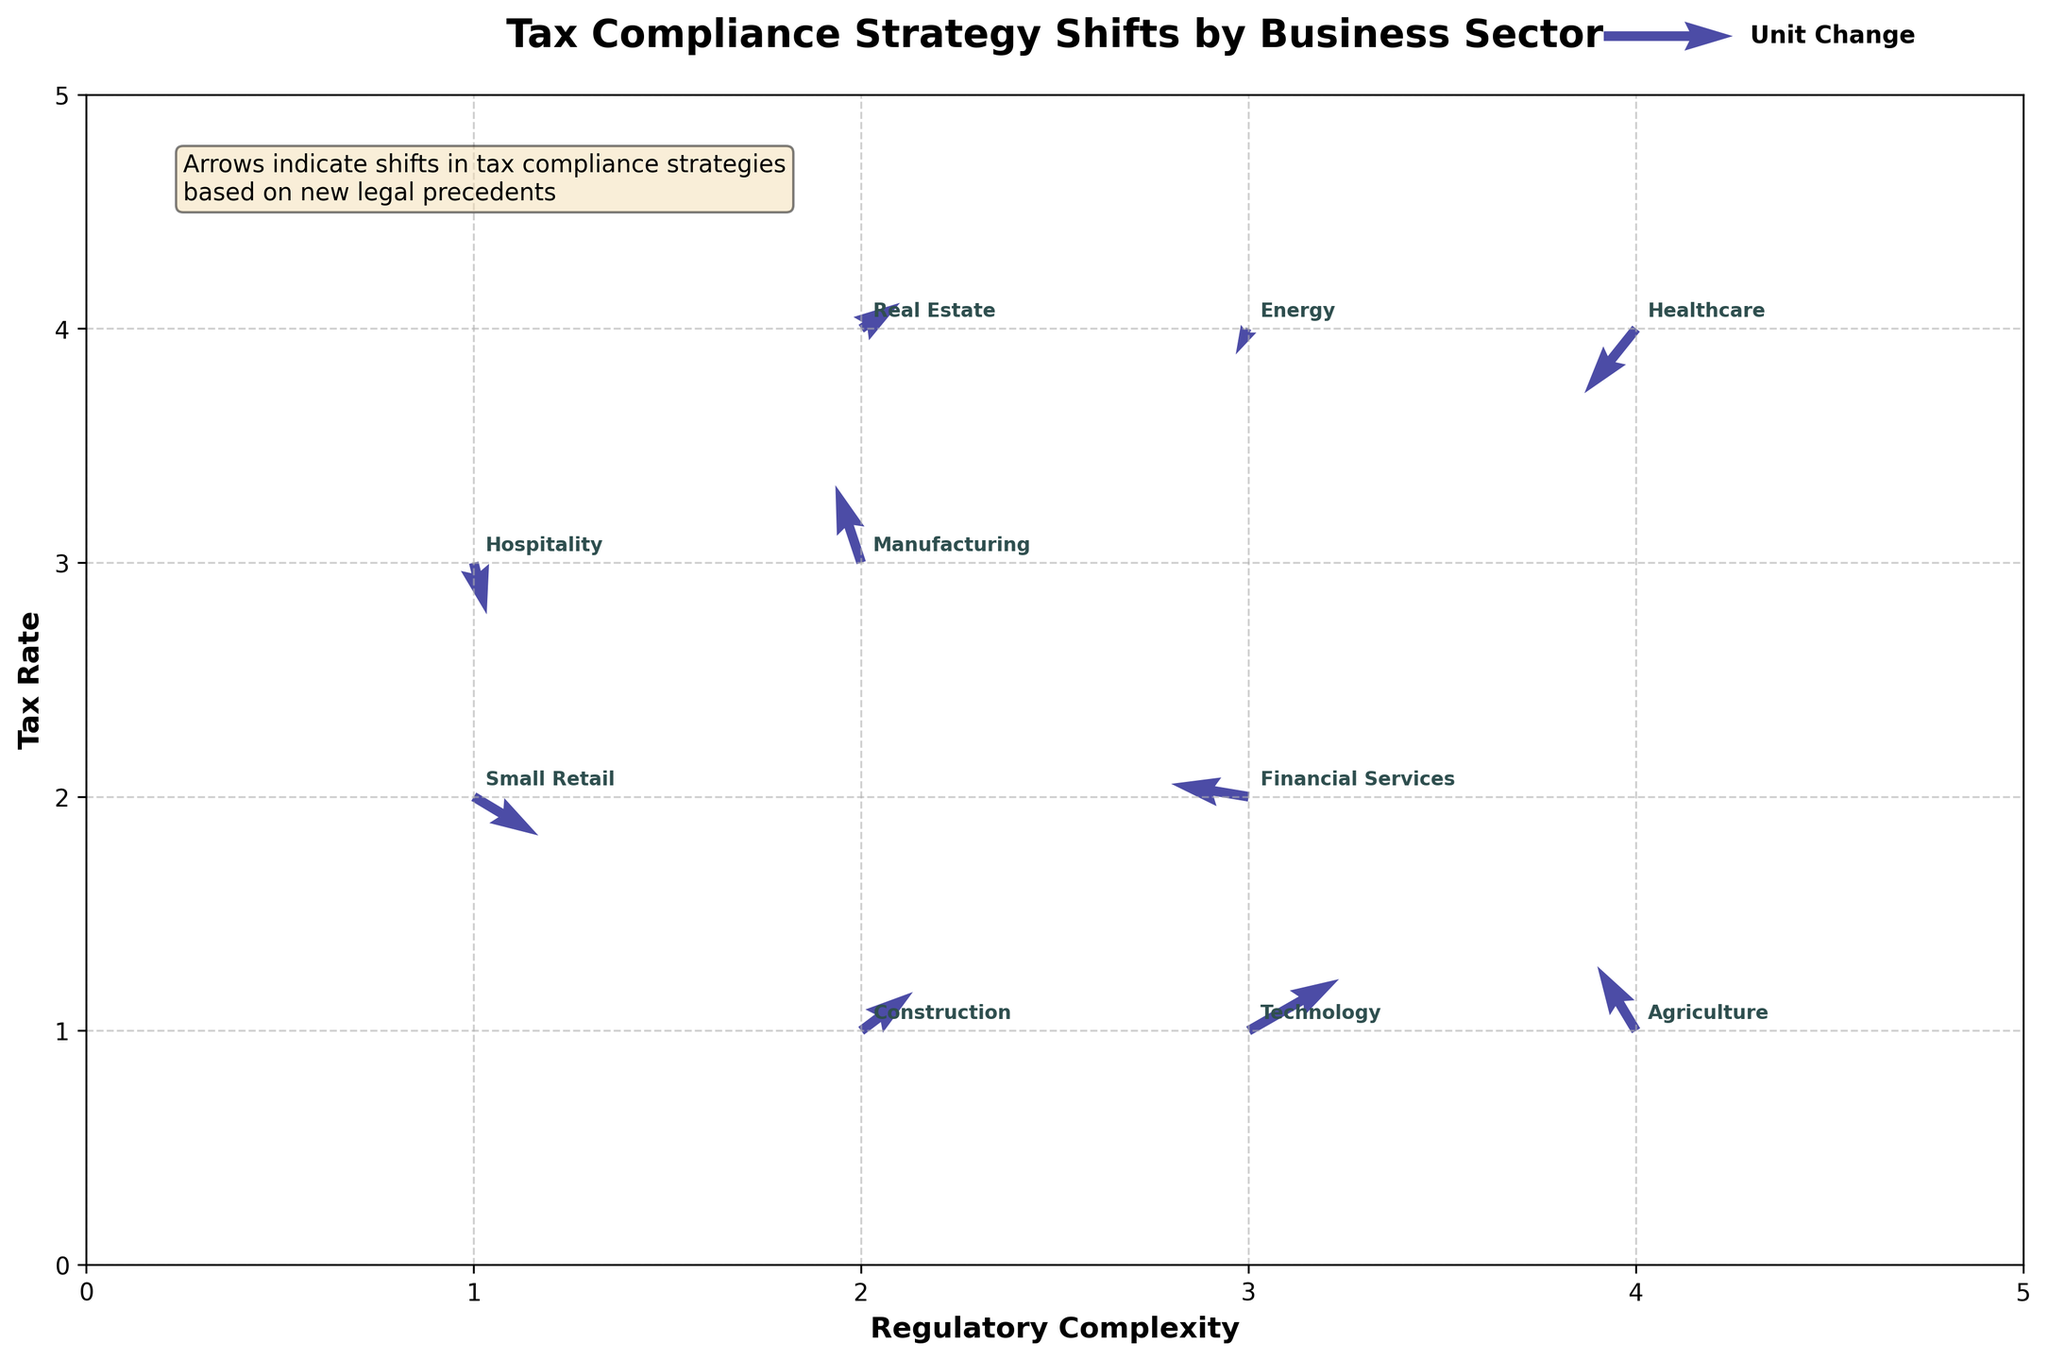What is the title of the plot? The title of the plot is located at the top center of the figure. It reads "Tax Compliance Strategy Shifts by Business Sector."
Answer: Tax Compliance Strategy Shifts by Business Sector Which sector experienced the largest shift in the direction of increased regulatory complexity and tax rate? The arrow with the largest u and v components in the positive direction represents the largest shift. The Technology sector shows the largest shift with u=0.7 and v=0.4.
Answer: Technology Which business sector experienced a shift towards decreased regulatory complexity and tax rate? We need to identify the arrow with the largest negative u and v components. The Healthcare sector shows this shift with u=-0.4 and v=-0.5.
Answer: Healthcare What is the tax rate value for the Financial Services sector before the shift? The initial y-coordinate represents the tax rate before the shift. For Financial Services, the initial y-coordinate is 2.
Answer: 2 How many sectors show a shift involving a positive tax rate change? Count the arrows with a positive v component. The sectors are Manufacturing, Technology, Real Estate, Agriculture, and Construction, totaling 5.
Answer: 5 What is the net horizontal shift for the sectors Construction and Financial Services combined? Add the u components of both sectors. Construction has 0.4 and Financial Services has -0.6, leading to 0.4 + (-0.6) = -0.2.
Answer: -0.2 Which sector had the smallest shift in regulatory complexity, and what was its direction? Identify the arrow with the smallest absolute value of u. Hospitality has u=0.1, and the direction is positive.
Answer: Hospitality, positive What are the initial coordinates for the Agriculture sector before the shift? The initial coordinates are given by the (x, y) position in the plot for Agriculture, which are (4, 1).
Answer: (4, 1) Compare the vertical shifts in tax rate for the Manufacturing and Energy sectors. Which sector had a greater positive or smaller negative shift? Both v values must be examined. Manufacturing has v=0.6, and Energy has v=-0.2. Manufacturing had a greater positive shift.
Answer: Manufacturing 